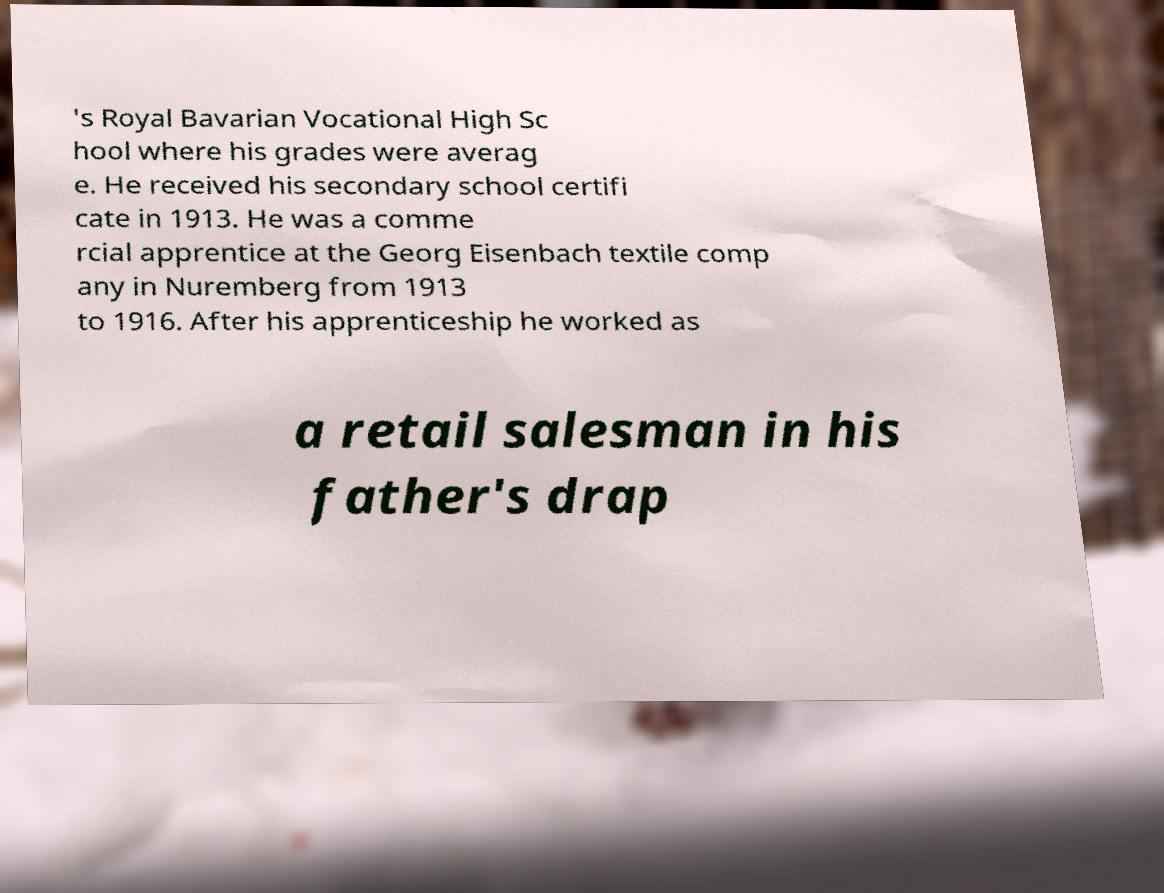What messages or text are displayed in this image? I need them in a readable, typed format. 's Royal Bavarian Vocational High Sc hool where his grades were averag e. He received his secondary school certifi cate in 1913. He was a comme rcial apprentice at the Georg Eisenbach textile comp any in Nuremberg from 1913 to 1916. After his apprenticeship he worked as a retail salesman in his father's drap 